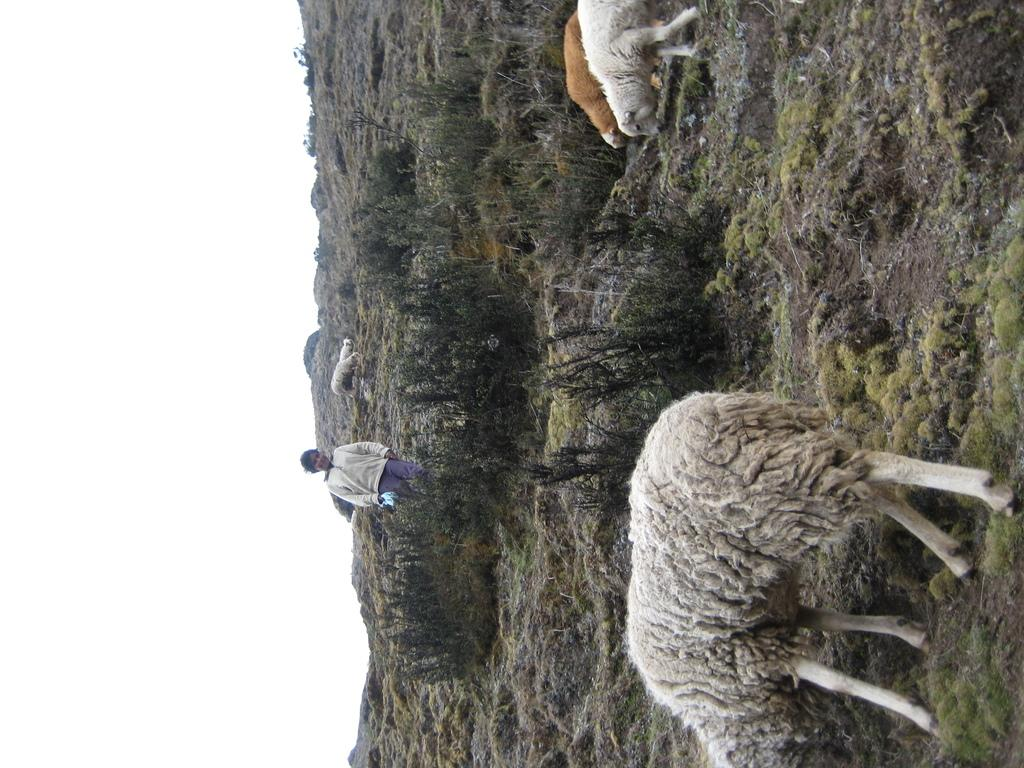Who or what is present in the image? There is a person and sheep in the image. What type of environment is depicted in the image? The image shows grass and plants, suggesting a natural setting. What can be seen in the background of the image? The sky is clear in the background of the image. How do the pets interact with the pig in the image? There are no pets or pigs present in the image; it features a person and sheep. 